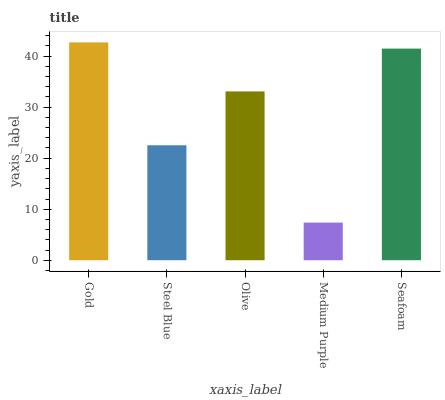Is Medium Purple the minimum?
Answer yes or no. Yes. Is Gold the maximum?
Answer yes or no. Yes. Is Steel Blue the minimum?
Answer yes or no. No. Is Steel Blue the maximum?
Answer yes or no. No. Is Gold greater than Steel Blue?
Answer yes or no. Yes. Is Steel Blue less than Gold?
Answer yes or no. Yes. Is Steel Blue greater than Gold?
Answer yes or no. No. Is Gold less than Steel Blue?
Answer yes or no. No. Is Olive the high median?
Answer yes or no. Yes. Is Olive the low median?
Answer yes or no. Yes. Is Medium Purple the high median?
Answer yes or no. No. Is Steel Blue the low median?
Answer yes or no. No. 